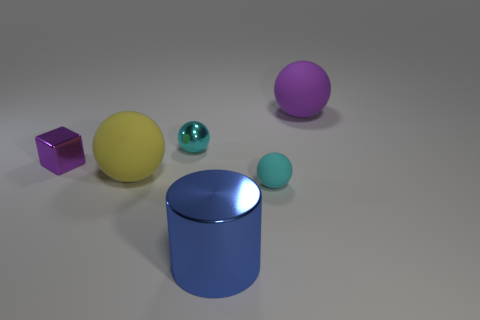What is the texture of the surface on which the objects are placed? The surface underneath the objects has a matte, slightly textured finish, which suggests it could be a material like brushed metal or a synthetic matte finish typically used in photography or rendering for visually pleasing backdrops. Could you describe the colors of the objects? Certainly, the objects display a range of colors: the cube has a reflective purple surface, the largest sphere is yellow, the smallest sphere is cyan, a smaller sphere has a turquoise tint, and the cylindrical object features a bright blue color. 